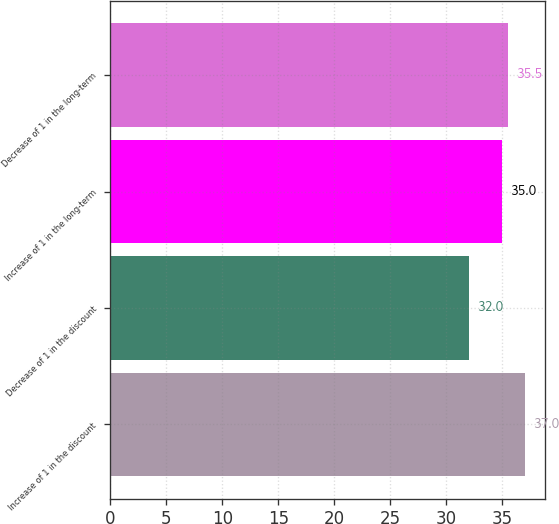<chart> <loc_0><loc_0><loc_500><loc_500><bar_chart><fcel>Increase of 1 in the discount<fcel>Decrease of 1 in the discount<fcel>Increase of 1 in the long-term<fcel>Decrease of 1 in the long-term<nl><fcel>37<fcel>32<fcel>35<fcel>35.5<nl></chart> 